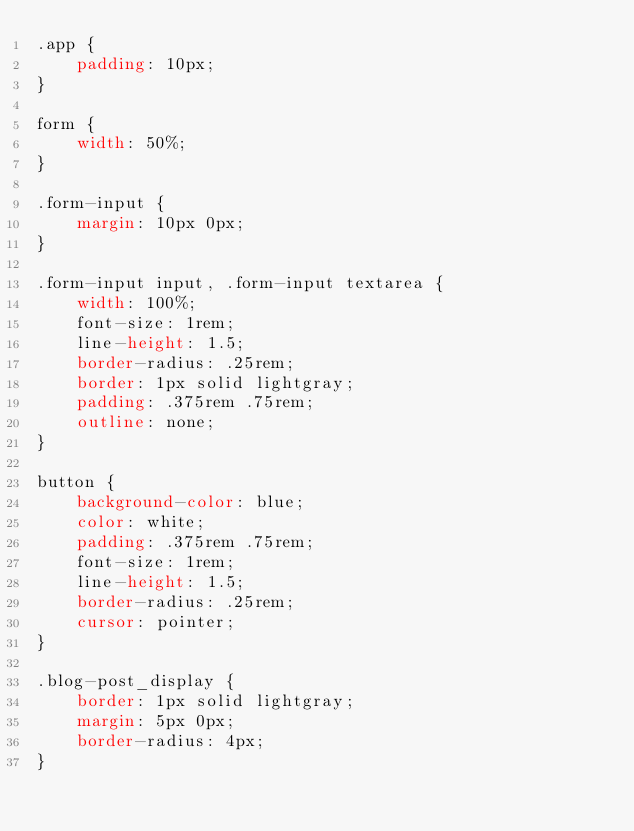<code> <loc_0><loc_0><loc_500><loc_500><_CSS_>.app {
    padding: 10px;
}

form {
    width: 50%;
}

.form-input {
    margin: 10px 0px;
}

.form-input input, .form-input textarea {
    width: 100%;
    font-size: 1rem;
    line-height: 1.5;
    border-radius: .25rem;
    border: 1px solid lightgray;
    padding: .375rem .75rem;
    outline: none;
}

button {
    background-color: blue;
    color: white;
    padding: .375rem .75rem;
    font-size: 1rem;
    line-height: 1.5;
    border-radius: .25rem;
    cursor: pointer;
}

.blog-post_display {
    border: 1px solid lightgray;
    margin: 5px 0px;
    border-radius: 4px;
}

</code> 